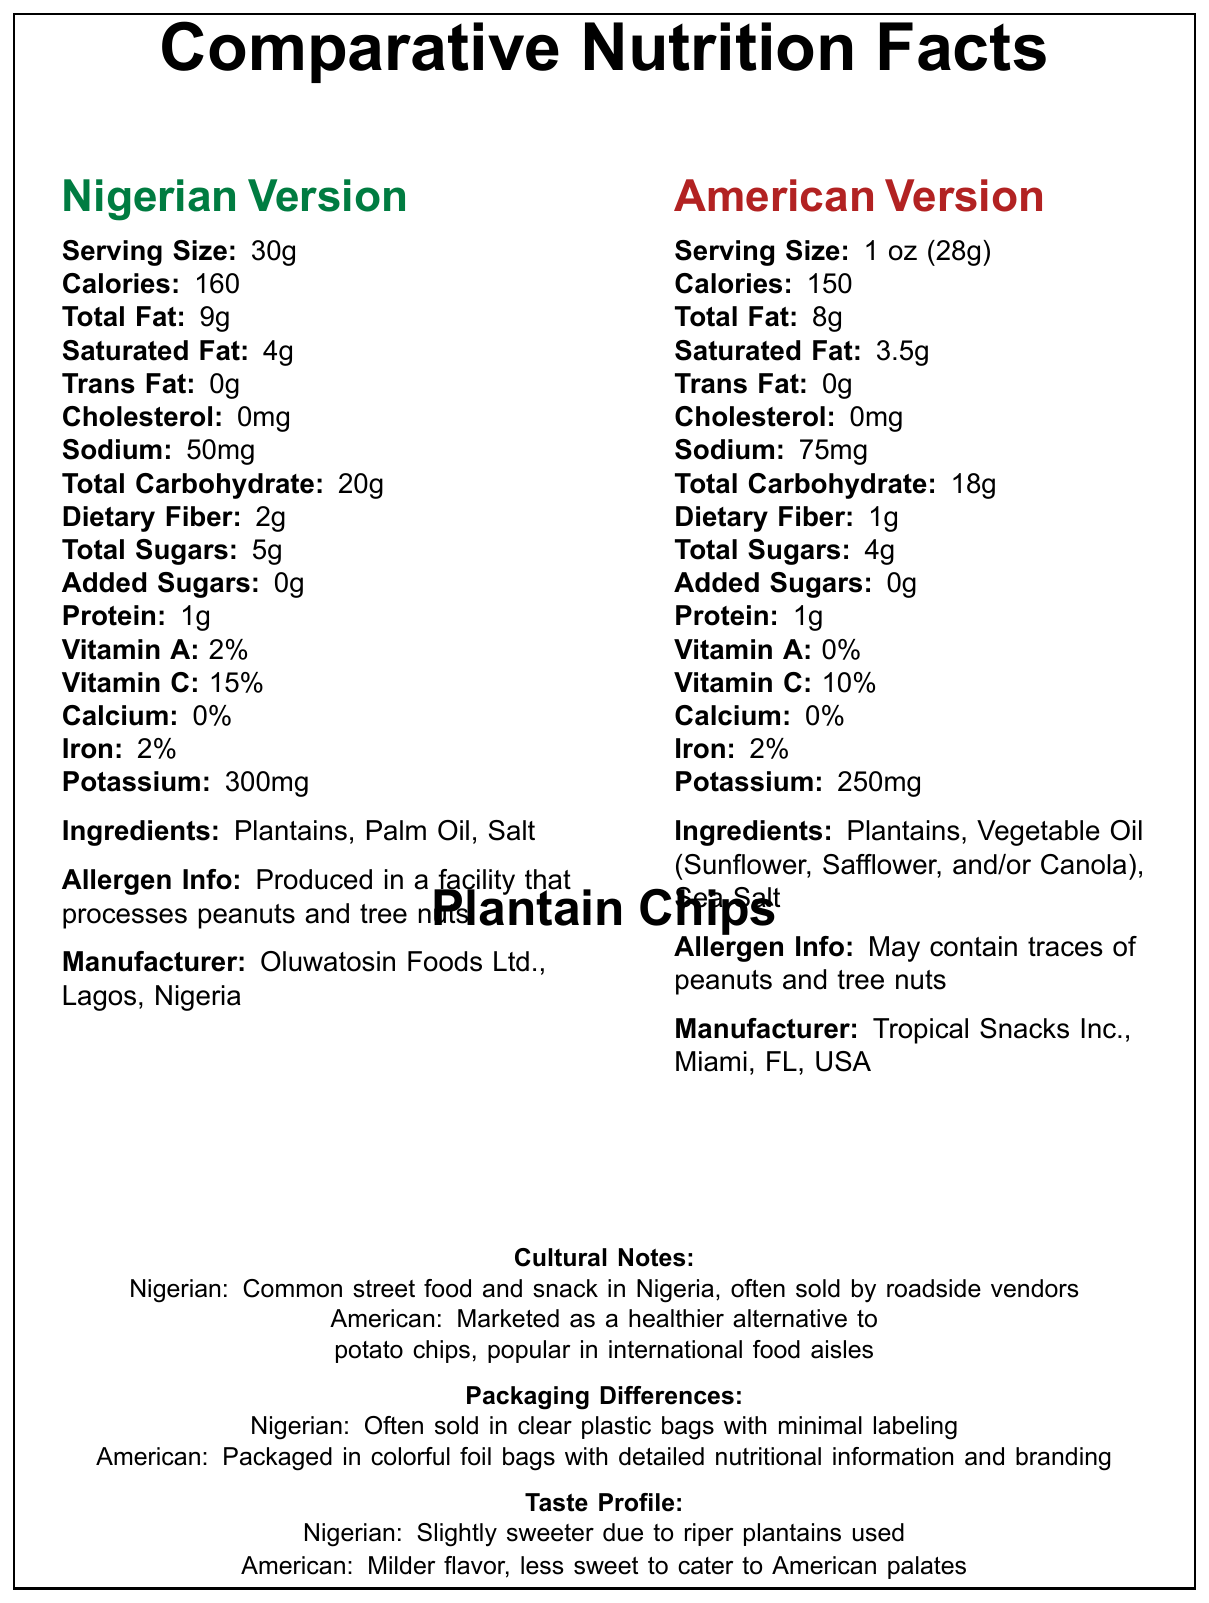what is the serving size of the Nigerian version of Plantain Chips? The serving size for the Nigerian version is listed as 30g in the document.
Answer: 30g what is the difference in sodium content between the Nigerian and American versions? The Nigerian version has 50mg of sodium, while the American version has 75mg, resulting in a 25mg difference.
Answer: 25mg how much dietary fiber does the American version contain? The document states that the American version of Plantain Chips contains 1g of dietary fiber.
Answer: 1g which version has a higher calorie count? The Nigerian version has 160 calories, while the American version has 150 calories.
Answer: Nigerian version who is the manufacturer for the American version? The document lists Tropical Snacks Inc., Miami, FL, USA as the manufacturer for the American version.
Answer: Tropical Snacks Inc., Miami, FL, USA which version contains more Vitamin C? A. Nigerian version B. American version The Nigerian version contains 15% of Vitamin C, while the American version contains 10%.
Answer: A what type of oil is used in the Nigerian version? The ingredients for the Nigerian version list Palm Oil.
Answer: Palm Oil which version has lower total sugars? 1. Nigerian 2. American 3. Both have the same amount The document shows that the Nigerian version contains 5g of total sugars, while the American version contains 4g.
Answer: 2. American are both versions free of added sugars? The document specifies that both have 0g of added sugars.
Answer: Yes what are some packaging differences between the Nigerian and American versions of Plantain Chips? The document describes that the Nigerian version is often sold in clear plastic bags with minimal labeling, and the American version is colored foil bags with detailed nutritional information and branding.
Answer: Nigerian version is often sold in clear plastic bags with minimal labeling, while the American version is packaged in colorful foil bags with detailed nutritional information and branding. which version is considered a common street food in its country? The cultural notes indicate that Plantain Chips are a common street food and snack in Nigeria.
Answer: Nigerian version explain the allergen information for both versions? According to the allergen information section, the Nigerian version is produced in a facility that processes peanuts and tree nuts. The American version may contain traces of peanuts and tree nuts.
Answer: The Nigerian version is produced in a facility that processes peanuts and tree nuts, while the American version may contain traces of peanuts and tree nuts. summarize the main differences between the Nigerian and American versions of Plantain Chips. The document highlights several nutritional differences, ingredient variations, cultural contexts, and packaging styles between the Nigerian and American versions of Plantain Chips.
Answer: The Nigerian and American versions of Plantain Chips differ in serving size, calorie content, sodium content, dietary fiber, ingredient list, cultural context, and packaging. The Nigerian version has a serving size of 30g with 160 calories, lower sodium (50mg), and higher dietary fiber (2g). It uses palm oil and has a sweeter taste due to riper plantains. The American version has a serving size of 1 oz (28g) with 150 calories, higher sodium (75mg), and lower dietary fiber (1g). It uses a blend of vegetable oils and sea salt. The Nigerian version is a common street food often sold in clear plastic bags, whereas the American version is marketed as a healthier alternative to potato chips and is sold in colorful foil bags. which ingredients make the American version of Plantain Chips? The ingredients section lists these components for the American version.
Answer: Plantains, Vegetable Oil (Sunflower, Safflower, and/or Canola), Sea Salt what is the production location for the Nigerian version's manufacturer? The document states that Oluwatosin Foods Ltd. in Lagos, Nigeria, manufactures the Nigerian version.
Answer: Lagos, Nigeria what inspired the American version's milder flavor? The taste profile notes that the American version has a milder flavor that is less sweet to cater to American palates.
Answer: Less sweet to cater to American palates how is the Nigerian version marketed? The cultural notes describe it as a common street food in Nigeria, often sold by roadside vendors.
Answer: Common street food and snack in Nigeria, often sold by roadside vendors why is the Nigerian version sweeter? The taste profile states that the Nigerian version is slightly sweeter due to the use of riper plantains.
Answer: Slightly sweeter due to riper plantains used what is the exact amount of potassium in the Nigerian and American versions? The document specifies that the Nigerian version has 300mg of potassium, while the American version has 250mg.
Answer: Nigerian: 300mg, American: 250mg does the document mention the price of either version? The document does not provide any pricing information for either version.
Answer: Not enough information 